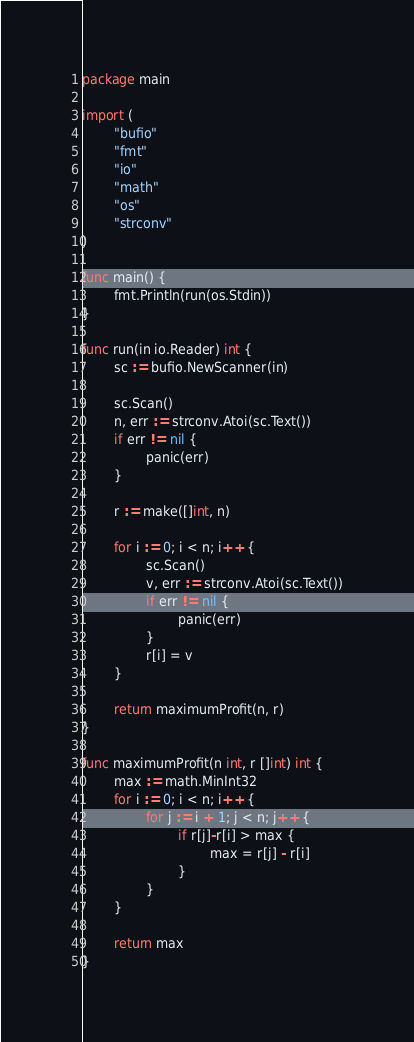Convert code to text. <code><loc_0><loc_0><loc_500><loc_500><_Go_>package main

import (
        "bufio"
        "fmt"
        "io"
        "math"
        "os"
        "strconv"
)

func main() {
        fmt.Println(run(os.Stdin))
}

func run(in io.Reader) int {
        sc := bufio.NewScanner(in)

        sc.Scan()
        n, err := strconv.Atoi(sc.Text())
        if err != nil {
                panic(err)
        }

        r := make([]int, n)

        for i := 0; i < n; i++ {
                sc.Scan()
                v, err := strconv.Atoi(sc.Text())
                if err != nil {
                        panic(err)
                }
                r[i] = v
        }

        return maximumProfit(n, r)
}

func maximumProfit(n int, r []int) int {
        max := math.MinInt32
        for i := 0; i < n; i++ {
                for j := i + 1; j < n; j++ {
                        if r[j]-r[i] > max {
                                max = r[j] - r[i]
                        }
                }
        }

        return max
}

</code> 